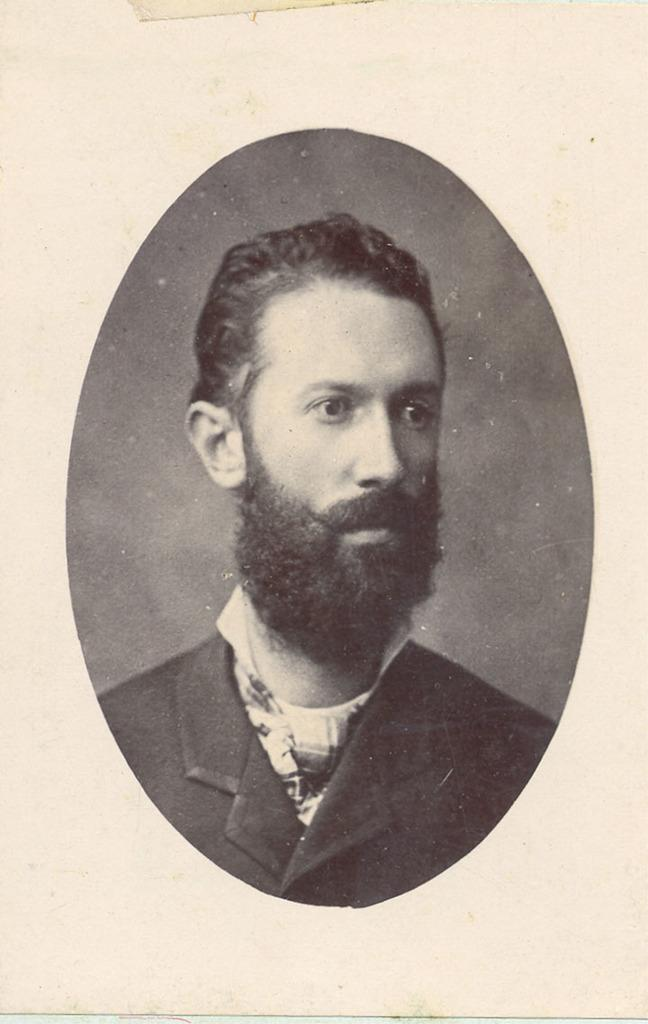What is the color scheme of the image? The image is black and white. Can you describe the person in the image? There is a man in the image. What is the man wearing in the image? The man is wearing a black coat. What is the title of the book the man is holding in the image? There is no book visible in the image, and therefore no title can be determined. 